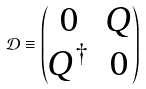Convert formula to latex. <formula><loc_0><loc_0><loc_500><loc_500>\mathcal { D } \equiv \begin{pmatrix} 0 & Q \\ Q ^ { \dagger } & 0 \end{pmatrix}</formula> 